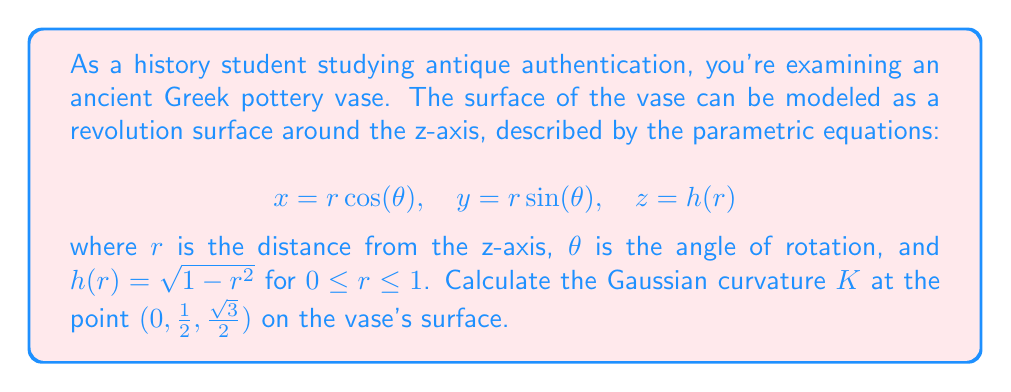Could you help me with this problem? To solve this problem, we'll follow these steps:

1) First, we need to understand that the Gaussian curvature $K$ for a surface of revolution is given by:

   $$ K = -\frac{h''(r)}{h'(r)(1 + (h'(r))^2)^{1/2}} $$

2) We need to find $h'(r)$ and $h''(r)$:
   
   $h(r) = \sqrt{1-r^2}$
   
   $h'(r) = -\frac{r}{\sqrt{1-r^2}}$
   
   $h''(r) = -\frac{1}{(1-r^2)^{3/2}}$

3) At the point $(0, \frac{1}{2}, \frac{\sqrt{3}}{2})$, we have $r = \frac{1}{2}$. Let's substitute this:

   $h'(\frac{1}{2}) = -\frac{\frac{1}{2}}{\sqrt{1-(\frac{1}{2})^2}} = -\frac{1}{\sqrt{3}}$
   
   $h''(\frac{1}{2}) = -\frac{1}{(1-(\frac{1}{2})^2)^{3/2}} = -\frac{4}{3\sqrt{3}}$

4) Now we can substitute these values into the formula for $K$:

   $$ K = -\frac{h''(\frac{1}{2})}{h'(\frac{1}{2})(1 + (h'(\frac{1}{2}))^2)^{1/2}} $$

   $$ = -\frac{-\frac{4}{3\sqrt{3}}}{-\frac{1}{\sqrt{3}}(1 + (\frac{1}{\sqrt{3}})^2)^{1/2}} $$

5) Simplify:

   $$ = \frac{4}{3\sqrt{3}} \cdot \frac{\sqrt{3}}{(1 + \frac{1}{3})^{1/2}} = \frac{4}{3} \cdot \frac{1}{(\frac{4}{3})^{1/2}} = \frac{4}{3} \cdot \frac{\sqrt{3}}{2} = \frac{2\sqrt{3}}{3} $$

Thus, the Gaussian curvature at the point $(0, \frac{1}{2}, \frac{\sqrt{3}}{2})$ is $\frac{2\sqrt{3}}{3}$.
Answer: $K = \frac{2\sqrt{3}}{3}$ 